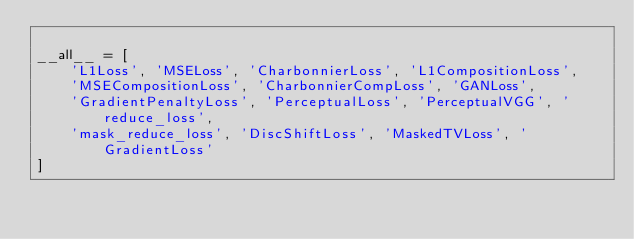<code> <loc_0><loc_0><loc_500><loc_500><_Python_>
__all__ = [
    'L1Loss', 'MSELoss', 'CharbonnierLoss', 'L1CompositionLoss',
    'MSECompositionLoss', 'CharbonnierCompLoss', 'GANLoss',
    'GradientPenaltyLoss', 'PerceptualLoss', 'PerceptualVGG', 'reduce_loss',
    'mask_reduce_loss', 'DiscShiftLoss', 'MaskedTVLoss', 'GradientLoss'
]
</code> 